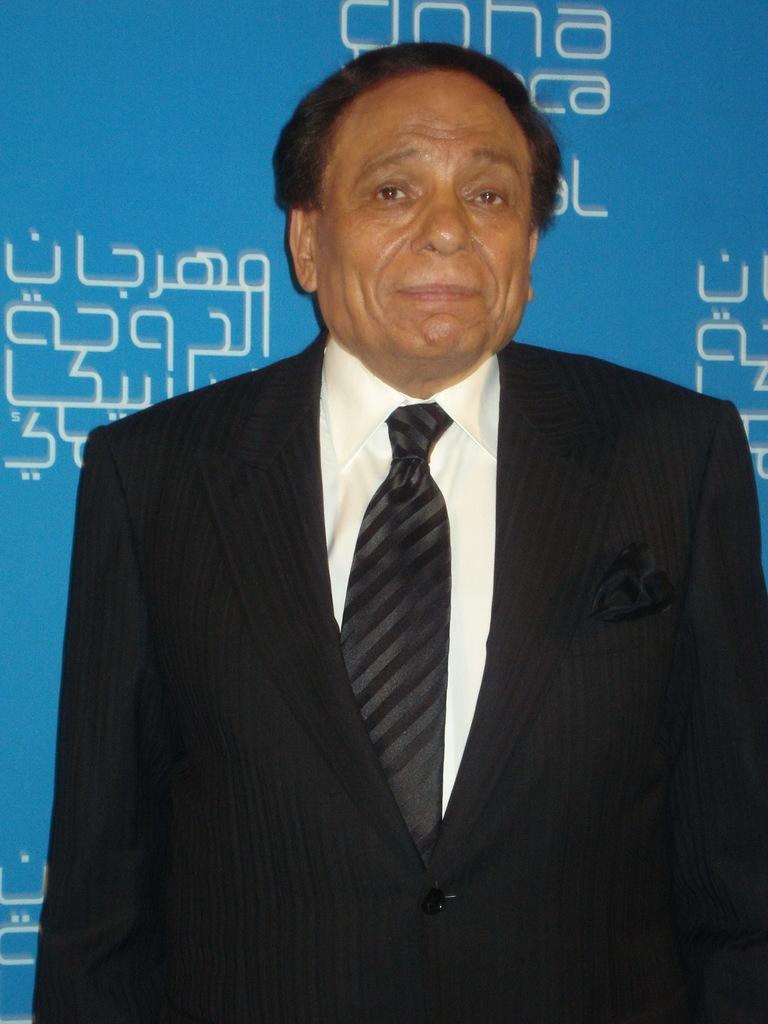Please provide a concise description of this image. In this image in front there is a person. Behind him there is a banner. 